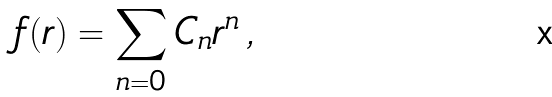Convert formula to latex. <formula><loc_0><loc_0><loc_500><loc_500>f ( r ) = \sum _ { n = 0 } C _ { n } r ^ { n } \, ,</formula> 